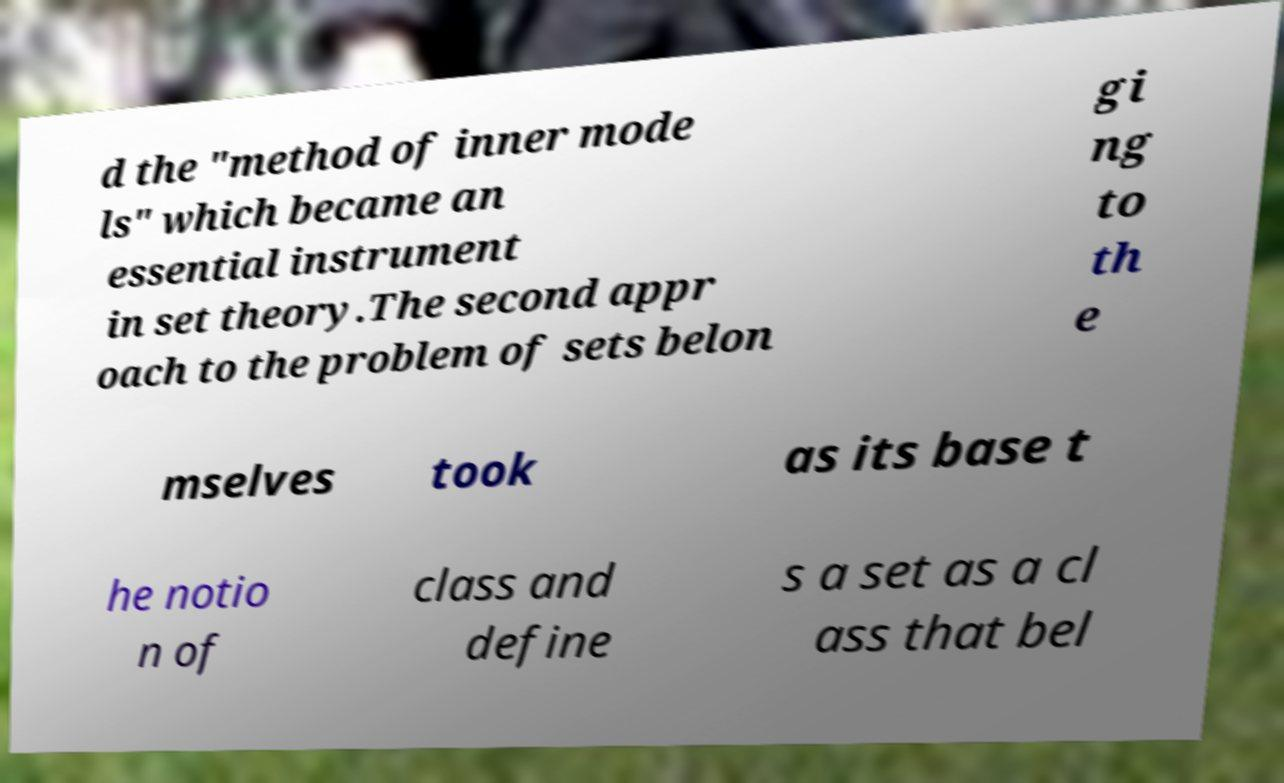Please identify and transcribe the text found in this image. d the "method of inner mode ls" which became an essential instrument in set theory.The second appr oach to the problem of sets belon gi ng to th e mselves took as its base t he notio n of class and define s a set as a cl ass that bel 